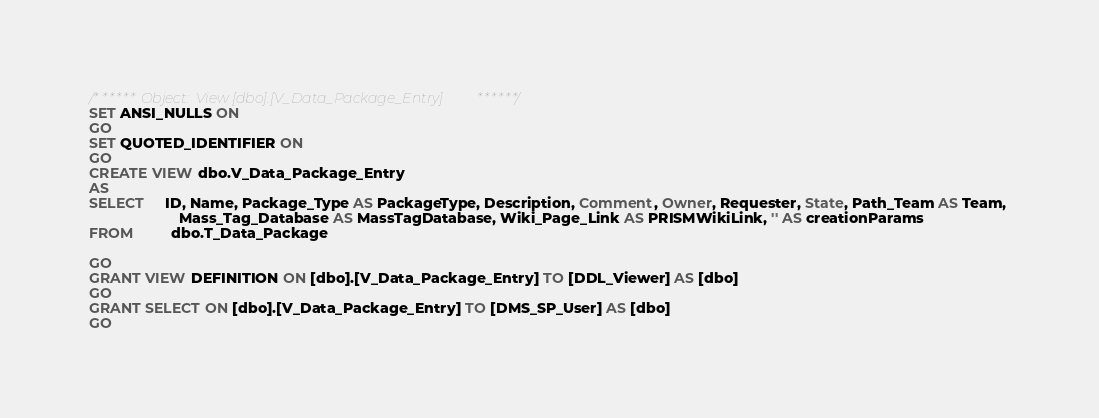Convert code to text. <code><loc_0><loc_0><loc_500><loc_500><_SQL_>/****** Object:  View [dbo].[V_Data_Package_Entry] ******/
SET ANSI_NULLS ON
GO
SET QUOTED_IDENTIFIER ON
GO
CREATE VIEW dbo.V_Data_Package_Entry
AS
SELECT     ID, Name, Package_Type AS PackageType, Description, Comment, Owner, Requester, State, Path_Team AS Team, 
                      Mass_Tag_Database AS MassTagDatabase, Wiki_Page_Link AS PRISMWikiLink, '' AS creationParams
FROM         dbo.T_Data_Package

GO
GRANT VIEW DEFINITION ON [dbo].[V_Data_Package_Entry] TO [DDL_Viewer] AS [dbo]
GO
GRANT SELECT ON [dbo].[V_Data_Package_Entry] TO [DMS_SP_User] AS [dbo]
GO
</code> 